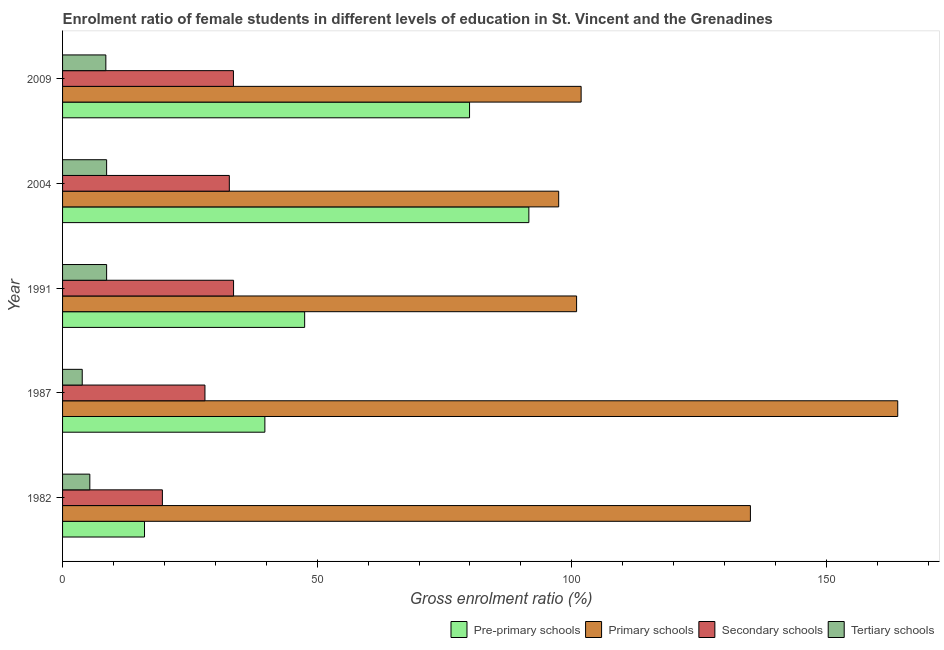How many different coloured bars are there?
Your response must be concise. 4. How many groups of bars are there?
Your answer should be very brief. 5. Are the number of bars per tick equal to the number of legend labels?
Keep it short and to the point. Yes. What is the gross enrolment ratio(male) in primary schools in 2009?
Offer a very short reply. 101.83. Across all years, what is the maximum gross enrolment ratio(male) in pre-primary schools?
Your answer should be compact. 91.57. Across all years, what is the minimum gross enrolment ratio(male) in tertiary schools?
Keep it short and to the point. 3.86. What is the total gross enrolment ratio(male) in primary schools in the graph?
Offer a very short reply. 599.29. What is the difference between the gross enrolment ratio(male) in primary schools in 1982 and that in 1987?
Your answer should be compact. -28.93. What is the difference between the gross enrolment ratio(male) in secondary schools in 1982 and the gross enrolment ratio(male) in tertiary schools in 2004?
Ensure brevity in your answer.  10.95. What is the average gross enrolment ratio(male) in tertiary schools per year?
Offer a terse response. 7. In the year 2004, what is the difference between the gross enrolment ratio(male) in tertiary schools and gross enrolment ratio(male) in pre-primary schools?
Your answer should be very brief. -82.92. In how many years, is the gross enrolment ratio(male) in tertiary schools greater than 90 %?
Provide a short and direct response. 0. What is the ratio of the gross enrolment ratio(male) in primary schools in 1982 to that in 1991?
Your answer should be very brief. 1.34. Is the gross enrolment ratio(male) in pre-primary schools in 1982 less than that in 1991?
Your answer should be very brief. Yes. Is the difference between the gross enrolment ratio(male) in primary schools in 1982 and 1987 greater than the difference between the gross enrolment ratio(male) in tertiary schools in 1982 and 1987?
Provide a succinct answer. No. What is the difference between the highest and the second highest gross enrolment ratio(male) in primary schools?
Your response must be concise. 28.93. What is the difference between the highest and the lowest gross enrolment ratio(male) in secondary schools?
Offer a terse response. 13.98. Is it the case that in every year, the sum of the gross enrolment ratio(male) in tertiary schools and gross enrolment ratio(male) in pre-primary schools is greater than the sum of gross enrolment ratio(male) in primary schools and gross enrolment ratio(male) in secondary schools?
Give a very brief answer. Yes. What does the 1st bar from the top in 1987 represents?
Keep it short and to the point. Tertiary schools. What does the 3rd bar from the bottom in 1987 represents?
Provide a succinct answer. Secondary schools. Is it the case that in every year, the sum of the gross enrolment ratio(male) in pre-primary schools and gross enrolment ratio(male) in primary schools is greater than the gross enrolment ratio(male) in secondary schools?
Your answer should be compact. Yes. How many bars are there?
Provide a short and direct response. 20. Are all the bars in the graph horizontal?
Ensure brevity in your answer.  Yes. Does the graph contain grids?
Give a very brief answer. No. How are the legend labels stacked?
Your answer should be very brief. Horizontal. What is the title of the graph?
Keep it short and to the point. Enrolment ratio of female students in different levels of education in St. Vincent and the Grenadines. Does "Plant species" appear as one of the legend labels in the graph?
Your answer should be compact. No. What is the label or title of the X-axis?
Make the answer very short. Gross enrolment ratio (%). What is the Gross enrolment ratio (%) in Pre-primary schools in 1982?
Your answer should be very brief. 16.09. What is the Gross enrolment ratio (%) in Primary schools in 1982?
Ensure brevity in your answer.  135.08. What is the Gross enrolment ratio (%) of Secondary schools in 1982?
Provide a short and direct response. 19.6. What is the Gross enrolment ratio (%) in Tertiary schools in 1982?
Keep it short and to the point. 5.35. What is the Gross enrolment ratio (%) in Pre-primary schools in 1987?
Ensure brevity in your answer.  39.73. What is the Gross enrolment ratio (%) of Primary schools in 1987?
Offer a very short reply. 164.01. What is the Gross enrolment ratio (%) in Secondary schools in 1987?
Offer a terse response. 27.96. What is the Gross enrolment ratio (%) in Tertiary schools in 1987?
Keep it short and to the point. 3.86. What is the Gross enrolment ratio (%) of Pre-primary schools in 1991?
Offer a very short reply. 47.54. What is the Gross enrolment ratio (%) in Primary schools in 1991?
Give a very brief answer. 100.95. What is the Gross enrolment ratio (%) in Secondary schools in 1991?
Ensure brevity in your answer.  33.58. What is the Gross enrolment ratio (%) of Tertiary schools in 1991?
Your response must be concise. 8.65. What is the Gross enrolment ratio (%) of Pre-primary schools in 2004?
Your response must be concise. 91.57. What is the Gross enrolment ratio (%) of Primary schools in 2004?
Offer a very short reply. 97.43. What is the Gross enrolment ratio (%) of Secondary schools in 2004?
Keep it short and to the point. 32.75. What is the Gross enrolment ratio (%) of Tertiary schools in 2004?
Ensure brevity in your answer.  8.65. What is the Gross enrolment ratio (%) in Pre-primary schools in 2009?
Ensure brevity in your answer.  79.92. What is the Gross enrolment ratio (%) in Primary schools in 2009?
Offer a terse response. 101.83. What is the Gross enrolment ratio (%) of Secondary schools in 2009?
Offer a very short reply. 33.56. What is the Gross enrolment ratio (%) of Tertiary schools in 2009?
Provide a short and direct response. 8.5. Across all years, what is the maximum Gross enrolment ratio (%) of Pre-primary schools?
Offer a very short reply. 91.57. Across all years, what is the maximum Gross enrolment ratio (%) of Primary schools?
Your answer should be very brief. 164.01. Across all years, what is the maximum Gross enrolment ratio (%) of Secondary schools?
Your answer should be compact. 33.58. Across all years, what is the maximum Gross enrolment ratio (%) of Tertiary schools?
Give a very brief answer. 8.65. Across all years, what is the minimum Gross enrolment ratio (%) of Pre-primary schools?
Your answer should be very brief. 16.09. Across all years, what is the minimum Gross enrolment ratio (%) of Primary schools?
Your response must be concise. 97.43. Across all years, what is the minimum Gross enrolment ratio (%) in Secondary schools?
Your answer should be compact. 19.6. Across all years, what is the minimum Gross enrolment ratio (%) of Tertiary schools?
Keep it short and to the point. 3.86. What is the total Gross enrolment ratio (%) in Pre-primary schools in the graph?
Give a very brief answer. 274.86. What is the total Gross enrolment ratio (%) of Primary schools in the graph?
Your answer should be compact. 599.29. What is the total Gross enrolment ratio (%) in Secondary schools in the graph?
Your response must be concise. 147.45. What is the total Gross enrolment ratio (%) in Tertiary schools in the graph?
Your response must be concise. 35.02. What is the difference between the Gross enrolment ratio (%) of Pre-primary schools in 1982 and that in 1987?
Provide a succinct answer. -23.64. What is the difference between the Gross enrolment ratio (%) of Primary schools in 1982 and that in 1987?
Ensure brevity in your answer.  -28.93. What is the difference between the Gross enrolment ratio (%) in Secondary schools in 1982 and that in 1987?
Offer a very short reply. -8.36. What is the difference between the Gross enrolment ratio (%) in Tertiary schools in 1982 and that in 1987?
Offer a terse response. 1.49. What is the difference between the Gross enrolment ratio (%) in Pre-primary schools in 1982 and that in 1991?
Provide a short and direct response. -31.45. What is the difference between the Gross enrolment ratio (%) of Primary schools in 1982 and that in 1991?
Provide a succinct answer. 34.13. What is the difference between the Gross enrolment ratio (%) in Secondary schools in 1982 and that in 1991?
Provide a short and direct response. -13.98. What is the difference between the Gross enrolment ratio (%) in Tertiary schools in 1982 and that in 1991?
Offer a terse response. -3.3. What is the difference between the Gross enrolment ratio (%) of Pre-primary schools in 1982 and that in 2004?
Offer a terse response. -75.48. What is the difference between the Gross enrolment ratio (%) of Primary schools in 1982 and that in 2004?
Your answer should be very brief. 37.65. What is the difference between the Gross enrolment ratio (%) in Secondary schools in 1982 and that in 2004?
Your answer should be compact. -13.15. What is the difference between the Gross enrolment ratio (%) in Tertiary schools in 1982 and that in 2004?
Offer a terse response. -3.3. What is the difference between the Gross enrolment ratio (%) of Pre-primary schools in 1982 and that in 2009?
Make the answer very short. -63.83. What is the difference between the Gross enrolment ratio (%) in Primary schools in 1982 and that in 2009?
Provide a short and direct response. 33.24. What is the difference between the Gross enrolment ratio (%) of Secondary schools in 1982 and that in 2009?
Provide a short and direct response. -13.95. What is the difference between the Gross enrolment ratio (%) of Tertiary schools in 1982 and that in 2009?
Offer a terse response. -3.15. What is the difference between the Gross enrolment ratio (%) of Pre-primary schools in 1987 and that in 1991?
Offer a terse response. -7.81. What is the difference between the Gross enrolment ratio (%) in Primary schools in 1987 and that in 1991?
Keep it short and to the point. 63.06. What is the difference between the Gross enrolment ratio (%) of Secondary schools in 1987 and that in 1991?
Your answer should be very brief. -5.62. What is the difference between the Gross enrolment ratio (%) in Tertiary schools in 1987 and that in 1991?
Your answer should be compact. -4.79. What is the difference between the Gross enrolment ratio (%) in Pre-primary schools in 1987 and that in 2004?
Ensure brevity in your answer.  -51.84. What is the difference between the Gross enrolment ratio (%) in Primary schools in 1987 and that in 2004?
Give a very brief answer. 66.58. What is the difference between the Gross enrolment ratio (%) in Secondary schools in 1987 and that in 2004?
Keep it short and to the point. -4.79. What is the difference between the Gross enrolment ratio (%) in Tertiary schools in 1987 and that in 2004?
Ensure brevity in your answer.  -4.79. What is the difference between the Gross enrolment ratio (%) in Pre-primary schools in 1987 and that in 2009?
Your response must be concise. -40.19. What is the difference between the Gross enrolment ratio (%) in Primary schools in 1987 and that in 2009?
Provide a short and direct response. 62.17. What is the difference between the Gross enrolment ratio (%) in Secondary schools in 1987 and that in 2009?
Ensure brevity in your answer.  -5.59. What is the difference between the Gross enrolment ratio (%) of Tertiary schools in 1987 and that in 2009?
Your answer should be compact. -4.64. What is the difference between the Gross enrolment ratio (%) of Pre-primary schools in 1991 and that in 2004?
Offer a very short reply. -44.03. What is the difference between the Gross enrolment ratio (%) in Primary schools in 1991 and that in 2004?
Keep it short and to the point. 3.52. What is the difference between the Gross enrolment ratio (%) of Secondary schools in 1991 and that in 2004?
Offer a very short reply. 0.83. What is the difference between the Gross enrolment ratio (%) in Tertiary schools in 1991 and that in 2004?
Provide a short and direct response. 0. What is the difference between the Gross enrolment ratio (%) of Pre-primary schools in 1991 and that in 2009?
Make the answer very short. -32.38. What is the difference between the Gross enrolment ratio (%) of Primary schools in 1991 and that in 2009?
Provide a short and direct response. -0.89. What is the difference between the Gross enrolment ratio (%) of Secondary schools in 1991 and that in 2009?
Ensure brevity in your answer.  0.03. What is the difference between the Gross enrolment ratio (%) of Tertiary schools in 1991 and that in 2009?
Your response must be concise. 0.15. What is the difference between the Gross enrolment ratio (%) of Pre-primary schools in 2004 and that in 2009?
Keep it short and to the point. 11.65. What is the difference between the Gross enrolment ratio (%) of Primary schools in 2004 and that in 2009?
Your answer should be very brief. -4.41. What is the difference between the Gross enrolment ratio (%) in Secondary schools in 2004 and that in 2009?
Your response must be concise. -0.81. What is the difference between the Gross enrolment ratio (%) in Tertiary schools in 2004 and that in 2009?
Your response must be concise. 0.15. What is the difference between the Gross enrolment ratio (%) of Pre-primary schools in 1982 and the Gross enrolment ratio (%) of Primary schools in 1987?
Offer a very short reply. -147.91. What is the difference between the Gross enrolment ratio (%) in Pre-primary schools in 1982 and the Gross enrolment ratio (%) in Secondary schools in 1987?
Provide a succinct answer. -11.87. What is the difference between the Gross enrolment ratio (%) in Pre-primary schools in 1982 and the Gross enrolment ratio (%) in Tertiary schools in 1987?
Keep it short and to the point. 12.23. What is the difference between the Gross enrolment ratio (%) of Primary schools in 1982 and the Gross enrolment ratio (%) of Secondary schools in 1987?
Provide a short and direct response. 107.11. What is the difference between the Gross enrolment ratio (%) of Primary schools in 1982 and the Gross enrolment ratio (%) of Tertiary schools in 1987?
Provide a succinct answer. 131.22. What is the difference between the Gross enrolment ratio (%) of Secondary schools in 1982 and the Gross enrolment ratio (%) of Tertiary schools in 1987?
Give a very brief answer. 15.74. What is the difference between the Gross enrolment ratio (%) in Pre-primary schools in 1982 and the Gross enrolment ratio (%) in Primary schools in 1991?
Your response must be concise. -84.85. What is the difference between the Gross enrolment ratio (%) in Pre-primary schools in 1982 and the Gross enrolment ratio (%) in Secondary schools in 1991?
Your answer should be very brief. -17.49. What is the difference between the Gross enrolment ratio (%) in Pre-primary schools in 1982 and the Gross enrolment ratio (%) in Tertiary schools in 1991?
Provide a short and direct response. 7.44. What is the difference between the Gross enrolment ratio (%) in Primary schools in 1982 and the Gross enrolment ratio (%) in Secondary schools in 1991?
Offer a very short reply. 101.5. What is the difference between the Gross enrolment ratio (%) of Primary schools in 1982 and the Gross enrolment ratio (%) of Tertiary schools in 1991?
Provide a succinct answer. 126.42. What is the difference between the Gross enrolment ratio (%) in Secondary schools in 1982 and the Gross enrolment ratio (%) in Tertiary schools in 1991?
Make the answer very short. 10.95. What is the difference between the Gross enrolment ratio (%) in Pre-primary schools in 1982 and the Gross enrolment ratio (%) in Primary schools in 2004?
Provide a succinct answer. -81.33. What is the difference between the Gross enrolment ratio (%) of Pre-primary schools in 1982 and the Gross enrolment ratio (%) of Secondary schools in 2004?
Give a very brief answer. -16.66. What is the difference between the Gross enrolment ratio (%) in Pre-primary schools in 1982 and the Gross enrolment ratio (%) in Tertiary schools in 2004?
Ensure brevity in your answer.  7.44. What is the difference between the Gross enrolment ratio (%) in Primary schools in 1982 and the Gross enrolment ratio (%) in Secondary schools in 2004?
Provide a succinct answer. 102.33. What is the difference between the Gross enrolment ratio (%) in Primary schools in 1982 and the Gross enrolment ratio (%) in Tertiary schools in 2004?
Give a very brief answer. 126.43. What is the difference between the Gross enrolment ratio (%) in Secondary schools in 1982 and the Gross enrolment ratio (%) in Tertiary schools in 2004?
Keep it short and to the point. 10.95. What is the difference between the Gross enrolment ratio (%) of Pre-primary schools in 1982 and the Gross enrolment ratio (%) of Primary schools in 2009?
Offer a terse response. -85.74. What is the difference between the Gross enrolment ratio (%) of Pre-primary schools in 1982 and the Gross enrolment ratio (%) of Secondary schools in 2009?
Provide a succinct answer. -17.46. What is the difference between the Gross enrolment ratio (%) of Pre-primary schools in 1982 and the Gross enrolment ratio (%) of Tertiary schools in 2009?
Offer a very short reply. 7.59. What is the difference between the Gross enrolment ratio (%) of Primary schools in 1982 and the Gross enrolment ratio (%) of Secondary schools in 2009?
Offer a terse response. 101.52. What is the difference between the Gross enrolment ratio (%) of Primary schools in 1982 and the Gross enrolment ratio (%) of Tertiary schools in 2009?
Make the answer very short. 126.58. What is the difference between the Gross enrolment ratio (%) in Secondary schools in 1982 and the Gross enrolment ratio (%) in Tertiary schools in 2009?
Provide a succinct answer. 11.11. What is the difference between the Gross enrolment ratio (%) in Pre-primary schools in 1987 and the Gross enrolment ratio (%) in Primary schools in 1991?
Keep it short and to the point. -61.22. What is the difference between the Gross enrolment ratio (%) of Pre-primary schools in 1987 and the Gross enrolment ratio (%) of Secondary schools in 1991?
Offer a very short reply. 6.15. What is the difference between the Gross enrolment ratio (%) in Pre-primary schools in 1987 and the Gross enrolment ratio (%) in Tertiary schools in 1991?
Offer a very short reply. 31.08. What is the difference between the Gross enrolment ratio (%) in Primary schools in 1987 and the Gross enrolment ratio (%) in Secondary schools in 1991?
Your answer should be compact. 130.43. What is the difference between the Gross enrolment ratio (%) in Primary schools in 1987 and the Gross enrolment ratio (%) in Tertiary schools in 1991?
Offer a very short reply. 155.35. What is the difference between the Gross enrolment ratio (%) in Secondary schools in 1987 and the Gross enrolment ratio (%) in Tertiary schools in 1991?
Provide a short and direct response. 19.31. What is the difference between the Gross enrolment ratio (%) of Pre-primary schools in 1987 and the Gross enrolment ratio (%) of Primary schools in 2004?
Offer a terse response. -57.7. What is the difference between the Gross enrolment ratio (%) of Pre-primary schools in 1987 and the Gross enrolment ratio (%) of Secondary schools in 2004?
Your answer should be compact. 6.98. What is the difference between the Gross enrolment ratio (%) of Pre-primary schools in 1987 and the Gross enrolment ratio (%) of Tertiary schools in 2004?
Offer a very short reply. 31.08. What is the difference between the Gross enrolment ratio (%) of Primary schools in 1987 and the Gross enrolment ratio (%) of Secondary schools in 2004?
Your answer should be very brief. 131.26. What is the difference between the Gross enrolment ratio (%) of Primary schools in 1987 and the Gross enrolment ratio (%) of Tertiary schools in 2004?
Provide a succinct answer. 155.36. What is the difference between the Gross enrolment ratio (%) in Secondary schools in 1987 and the Gross enrolment ratio (%) in Tertiary schools in 2004?
Provide a short and direct response. 19.31. What is the difference between the Gross enrolment ratio (%) of Pre-primary schools in 1987 and the Gross enrolment ratio (%) of Primary schools in 2009?
Provide a short and direct response. -62.1. What is the difference between the Gross enrolment ratio (%) of Pre-primary schools in 1987 and the Gross enrolment ratio (%) of Secondary schools in 2009?
Ensure brevity in your answer.  6.17. What is the difference between the Gross enrolment ratio (%) of Pre-primary schools in 1987 and the Gross enrolment ratio (%) of Tertiary schools in 2009?
Your answer should be very brief. 31.23. What is the difference between the Gross enrolment ratio (%) of Primary schools in 1987 and the Gross enrolment ratio (%) of Secondary schools in 2009?
Your answer should be compact. 130.45. What is the difference between the Gross enrolment ratio (%) in Primary schools in 1987 and the Gross enrolment ratio (%) in Tertiary schools in 2009?
Your answer should be very brief. 155.51. What is the difference between the Gross enrolment ratio (%) in Secondary schools in 1987 and the Gross enrolment ratio (%) in Tertiary schools in 2009?
Offer a terse response. 19.46. What is the difference between the Gross enrolment ratio (%) in Pre-primary schools in 1991 and the Gross enrolment ratio (%) in Primary schools in 2004?
Give a very brief answer. -49.89. What is the difference between the Gross enrolment ratio (%) in Pre-primary schools in 1991 and the Gross enrolment ratio (%) in Secondary schools in 2004?
Ensure brevity in your answer.  14.79. What is the difference between the Gross enrolment ratio (%) of Pre-primary schools in 1991 and the Gross enrolment ratio (%) of Tertiary schools in 2004?
Your answer should be very brief. 38.89. What is the difference between the Gross enrolment ratio (%) in Primary schools in 1991 and the Gross enrolment ratio (%) in Secondary schools in 2004?
Your response must be concise. 68.2. What is the difference between the Gross enrolment ratio (%) of Primary schools in 1991 and the Gross enrolment ratio (%) of Tertiary schools in 2004?
Your answer should be compact. 92.29. What is the difference between the Gross enrolment ratio (%) of Secondary schools in 1991 and the Gross enrolment ratio (%) of Tertiary schools in 2004?
Your answer should be compact. 24.93. What is the difference between the Gross enrolment ratio (%) in Pre-primary schools in 1991 and the Gross enrolment ratio (%) in Primary schools in 2009?
Your answer should be compact. -54.29. What is the difference between the Gross enrolment ratio (%) of Pre-primary schools in 1991 and the Gross enrolment ratio (%) of Secondary schools in 2009?
Your answer should be compact. 13.99. What is the difference between the Gross enrolment ratio (%) of Pre-primary schools in 1991 and the Gross enrolment ratio (%) of Tertiary schools in 2009?
Ensure brevity in your answer.  39.04. What is the difference between the Gross enrolment ratio (%) of Primary schools in 1991 and the Gross enrolment ratio (%) of Secondary schools in 2009?
Offer a very short reply. 67.39. What is the difference between the Gross enrolment ratio (%) in Primary schools in 1991 and the Gross enrolment ratio (%) in Tertiary schools in 2009?
Make the answer very short. 92.45. What is the difference between the Gross enrolment ratio (%) in Secondary schools in 1991 and the Gross enrolment ratio (%) in Tertiary schools in 2009?
Make the answer very short. 25.08. What is the difference between the Gross enrolment ratio (%) of Pre-primary schools in 2004 and the Gross enrolment ratio (%) of Primary schools in 2009?
Ensure brevity in your answer.  -10.26. What is the difference between the Gross enrolment ratio (%) in Pre-primary schools in 2004 and the Gross enrolment ratio (%) in Secondary schools in 2009?
Keep it short and to the point. 58.01. What is the difference between the Gross enrolment ratio (%) of Pre-primary schools in 2004 and the Gross enrolment ratio (%) of Tertiary schools in 2009?
Your answer should be very brief. 83.07. What is the difference between the Gross enrolment ratio (%) in Primary schools in 2004 and the Gross enrolment ratio (%) in Secondary schools in 2009?
Provide a succinct answer. 63.87. What is the difference between the Gross enrolment ratio (%) in Primary schools in 2004 and the Gross enrolment ratio (%) in Tertiary schools in 2009?
Ensure brevity in your answer.  88.93. What is the difference between the Gross enrolment ratio (%) of Secondary schools in 2004 and the Gross enrolment ratio (%) of Tertiary schools in 2009?
Provide a succinct answer. 24.25. What is the average Gross enrolment ratio (%) in Pre-primary schools per year?
Ensure brevity in your answer.  54.97. What is the average Gross enrolment ratio (%) in Primary schools per year?
Keep it short and to the point. 119.86. What is the average Gross enrolment ratio (%) in Secondary schools per year?
Your answer should be compact. 29.49. What is the average Gross enrolment ratio (%) in Tertiary schools per year?
Ensure brevity in your answer.  7. In the year 1982, what is the difference between the Gross enrolment ratio (%) of Pre-primary schools and Gross enrolment ratio (%) of Primary schools?
Make the answer very short. -118.98. In the year 1982, what is the difference between the Gross enrolment ratio (%) of Pre-primary schools and Gross enrolment ratio (%) of Secondary schools?
Give a very brief answer. -3.51. In the year 1982, what is the difference between the Gross enrolment ratio (%) of Pre-primary schools and Gross enrolment ratio (%) of Tertiary schools?
Provide a short and direct response. 10.74. In the year 1982, what is the difference between the Gross enrolment ratio (%) of Primary schools and Gross enrolment ratio (%) of Secondary schools?
Make the answer very short. 115.47. In the year 1982, what is the difference between the Gross enrolment ratio (%) of Primary schools and Gross enrolment ratio (%) of Tertiary schools?
Provide a short and direct response. 129.72. In the year 1982, what is the difference between the Gross enrolment ratio (%) of Secondary schools and Gross enrolment ratio (%) of Tertiary schools?
Provide a succinct answer. 14.25. In the year 1987, what is the difference between the Gross enrolment ratio (%) in Pre-primary schools and Gross enrolment ratio (%) in Primary schools?
Make the answer very short. -124.28. In the year 1987, what is the difference between the Gross enrolment ratio (%) in Pre-primary schools and Gross enrolment ratio (%) in Secondary schools?
Your response must be concise. 11.77. In the year 1987, what is the difference between the Gross enrolment ratio (%) in Pre-primary schools and Gross enrolment ratio (%) in Tertiary schools?
Your response must be concise. 35.87. In the year 1987, what is the difference between the Gross enrolment ratio (%) in Primary schools and Gross enrolment ratio (%) in Secondary schools?
Provide a short and direct response. 136.05. In the year 1987, what is the difference between the Gross enrolment ratio (%) in Primary schools and Gross enrolment ratio (%) in Tertiary schools?
Offer a very short reply. 160.15. In the year 1987, what is the difference between the Gross enrolment ratio (%) of Secondary schools and Gross enrolment ratio (%) of Tertiary schools?
Your response must be concise. 24.1. In the year 1991, what is the difference between the Gross enrolment ratio (%) of Pre-primary schools and Gross enrolment ratio (%) of Primary schools?
Your response must be concise. -53.4. In the year 1991, what is the difference between the Gross enrolment ratio (%) of Pre-primary schools and Gross enrolment ratio (%) of Secondary schools?
Your answer should be very brief. 13.96. In the year 1991, what is the difference between the Gross enrolment ratio (%) of Pre-primary schools and Gross enrolment ratio (%) of Tertiary schools?
Provide a succinct answer. 38.89. In the year 1991, what is the difference between the Gross enrolment ratio (%) in Primary schools and Gross enrolment ratio (%) in Secondary schools?
Your answer should be compact. 67.36. In the year 1991, what is the difference between the Gross enrolment ratio (%) of Primary schools and Gross enrolment ratio (%) of Tertiary schools?
Make the answer very short. 92.29. In the year 1991, what is the difference between the Gross enrolment ratio (%) in Secondary schools and Gross enrolment ratio (%) in Tertiary schools?
Ensure brevity in your answer.  24.93. In the year 2004, what is the difference between the Gross enrolment ratio (%) of Pre-primary schools and Gross enrolment ratio (%) of Primary schools?
Offer a very short reply. -5.86. In the year 2004, what is the difference between the Gross enrolment ratio (%) of Pre-primary schools and Gross enrolment ratio (%) of Secondary schools?
Provide a succinct answer. 58.82. In the year 2004, what is the difference between the Gross enrolment ratio (%) of Pre-primary schools and Gross enrolment ratio (%) of Tertiary schools?
Make the answer very short. 82.92. In the year 2004, what is the difference between the Gross enrolment ratio (%) in Primary schools and Gross enrolment ratio (%) in Secondary schools?
Provide a short and direct response. 64.68. In the year 2004, what is the difference between the Gross enrolment ratio (%) of Primary schools and Gross enrolment ratio (%) of Tertiary schools?
Give a very brief answer. 88.78. In the year 2004, what is the difference between the Gross enrolment ratio (%) in Secondary schools and Gross enrolment ratio (%) in Tertiary schools?
Make the answer very short. 24.1. In the year 2009, what is the difference between the Gross enrolment ratio (%) of Pre-primary schools and Gross enrolment ratio (%) of Primary schools?
Make the answer very short. -21.91. In the year 2009, what is the difference between the Gross enrolment ratio (%) of Pre-primary schools and Gross enrolment ratio (%) of Secondary schools?
Offer a terse response. 46.37. In the year 2009, what is the difference between the Gross enrolment ratio (%) in Pre-primary schools and Gross enrolment ratio (%) in Tertiary schools?
Make the answer very short. 71.42. In the year 2009, what is the difference between the Gross enrolment ratio (%) in Primary schools and Gross enrolment ratio (%) in Secondary schools?
Provide a short and direct response. 68.28. In the year 2009, what is the difference between the Gross enrolment ratio (%) of Primary schools and Gross enrolment ratio (%) of Tertiary schools?
Ensure brevity in your answer.  93.34. In the year 2009, what is the difference between the Gross enrolment ratio (%) in Secondary schools and Gross enrolment ratio (%) in Tertiary schools?
Give a very brief answer. 25.06. What is the ratio of the Gross enrolment ratio (%) in Pre-primary schools in 1982 to that in 1987?
Ensure brevity in your answer.  0.41. What is the ratio of the Gross enrolment ratio (%) of Primary schools in 1982 to that in 1987?
Your answer should be compact. 0.82. What is the ratio of the Gross enrolment ratio (%) of Secondary schools in 1982 to that in 1987?
Offer a terse response. 0.7. What is the ratio of the Gross enrolment ratio (%) of Tertiary schools in 1982 to that in 1987?
Your response must be concise. 1.39. What is the ratio of the Gross enrolment ratio (%) of Pre-primary schools in 1982 to that in 1991?
Provide a succinct answer. 0.34. What is the ratio of the Gross enrolment ratio (%) of Primary schools in 1982 to that in 1991?
Provide a short and direct response. 1.34. What is the ratio of the Gross enrolment ratio (%) of Secondary schools in 1982 to that in 1991?
Give a very brief answer. 0.58. What is the ratio of the Gross enrolment ratio (%) of Tertiary schools in 1982 to that in 1991?
Your answer should be very brief. 0.62. What is the ratio of the Gross enrolment ratio (%) of Pre-primary schools in 1982 to that in 2004?
Your response must be concise. 0.18. What is the ratio of the Gross enrolment ratio (%) of Primary schools in 1982 to that in 2004?
Your response must be concise. 1.39. What is the ratio of the Gross enrolment ratio (%) of Secondary schools in 1982 to that in 2004?
Your answer should be very brief. 0.6. What is the ratio of the Gross enrolment ratio (%) of Tertiary schools in 1982 to that in 2004?
Your response must be concise. 0.62. What is the ratio of the Gross enrolment ratio (%) in Pre-primary schools in 1982 to that in 2009?
Your response must be concise. 0.2. What is the ratio of the Gross enrolment ratio (%) of Primary schools in 1982 to that in 2009?
Provide a short and direct response. 1.33. What is the ratio of the Gross enrolment ratio (%) of Secondary schools in 1982 to that in 2009?
Make the answer very short. 0.58. What is the ratio of the Gross enrolment ratio (%) in Tertiary schools in 1982 to that in 2009?
Make the answer very short. 0.63. What is the ratio of the Gross enrolment ratio (%) of Pre-primary schools in 1987 to that in 1991?
Offer a terse response. 0.84. What is the ratio of the Gross enrolment ratio (%) in Primary schools in 1987 to that in 1991?
Ensure brevity in your answer.  1.62. What is the ratio of the Gross enrolment ratio (%) in Secondary schools in 1987 to that in 1991?
Ensure brevity in your answer.  0.83. What is the ratio of the Gross enrolment ratio (%) in Tertiary schools in 1987 to that in 1991?
Provide a short and direct response. 0.45. What is the ratio of the Gross enrolment ratio (%) of Pre-primary schools in 1987 to that in 2004?
Make the answer very short. 0.43. What is the ratio of the Gross enrolment ratio (%) in Primary schools in 1987 to that in 2004?
Make the answer very short. 1.68. What is the ratio of the Gross enrolment ratio (%) in Secondary schools in 1987 to that in 2004?
Keep it short and to the point. 0.85. What is the ratio of the Gross enrolment ratio (%) of Tertiary schools in 1987 to that in 2004?
Offer a very short reply. 0.45. What is the ratio of the Gross enrolment ratio (%) of Pre-primary schools in 1987 to that in 2009?
Provide a short and direct response. 0.5. What is the ratio of the Gross enrolment ratio (%) of Primary schools in 1987 to that in 2009?
Give a very brief answer. 1.61. What is the ratio of the Gross enrolment ratio (%) in Secondary schools in 1987 to that in 2009?
Provide a succinct answer. 0.83. What is the ratio of the Gross enrolment ratio (%) in Tertiary schools in 1987 to that in 2009?
Your response must be concise. 0.45. What is the ratio of the Gross enrolment ratio (%) in Pre-primary schools in 1991 to that in 2004?
Make the answer very short. 0.52. What is the ratio of the Gross enrolment ratio (%) of Primary schools in 1991 to that in 2004?
Make the answer very short. 1.04. What is the ratio of the Gross enrolment ratio (%) of Secondary schools in 1991 to that in 2004?
Offer a terse response. 1.03. What is the ratio of the Gross enrolment ratio (%) of Tertiary schools in 1991 to that in 2004?
Offer a very short reply. 1. What is the ratio of the Gross enrolment ratio (%) in Pre-primary schools in 1991 to that in 2009?
Provide a short and direct response. 0.59. What is the ratio of the Gross enrolment ratio (%) of Tertiary schools in 1991 to that in 2009?
Your response must be concise. 1.02. What is the ratio of the Gross enrolment ratio (%) in Pre-primary schools in 2004 to that in 2009?
Your answer should be compact. 1.15. What is the ratio of the Gross enrolment ratio (%) in Primary schools in 2004 to that in 2009?
Offer a very short reply. 0.96. What is the ratio of the Gross enrolment ratio (%) in Secondary schools in 2004 to that in 2009?
Make the answer very short. 0.98. What is the ratio of the Gross enrolment ratio (%) of Tertiary schools in 2004 to that in 2009?
Ensure brevity in your answer.  1.02. What is the difference between the highest and the second highest Gross enrolment ratio (%) in Pre-primary schools?
Keep it short and to the point. 11.65. What is the difference between the highest and the second highest Gross enrolment ratio (%) in Primary schools?
Your answer should be very brief. 28.93. What is the difference between the highest and the second highest Gross enrolment ratio (%) of Secondary schools?
Offer a very short reply. 0.03. What is the difference between the highest and the second highest Gross enrolment ratio (%) of Tertiary schools?
Offer a very short reply. 0. What is the difference between the highest and the lowest Gross enrolment ratio (%) in Pre-primary schools?
Your response must be concise. 75.48. What is the difference between the highest and the lowest Gross enrolment ratio (%) of Primary schools?
Keep it short and to the point. 66.58. What is the difference between the highest and the lowest Gross enrolment ratio (%) in Secondary schools?
Your answer should be very brief. 13.98. What is the difference between the highest and the lowest Gross enrolment ratio (%) in Tertiary schools?
Offer a very short reply. 4.79. 